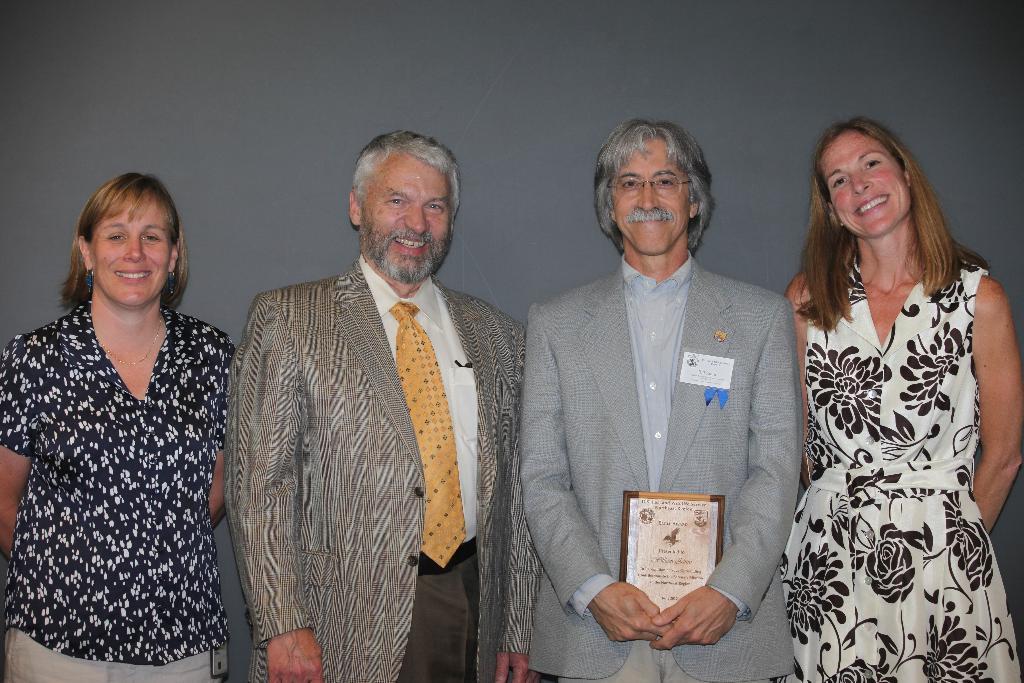How would you summarize this image in a sentence or two? In this image I can see in the middle two women are standing, they are wearing coats, shirts. Two women are there on either side of this image. All of them are smiling. 